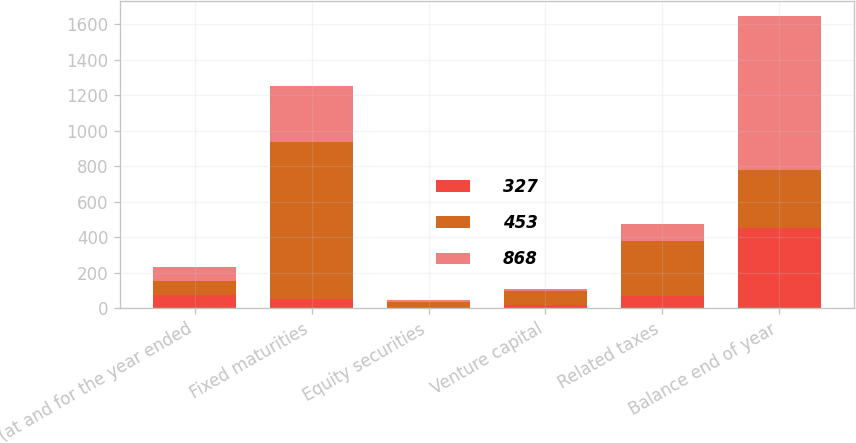<chart> <loc_0><loc_0><loc_500><loc_500><stacked_bar_chart><ecel><fcel>(at and for the year ended<fcel>Fixed maturities<fcel>Equity securities<fcel>Venture capital<fcel>Related taxes<fcel>Balance end of year<nl><fcel>327<fcel>78<fcel>55<fcel>4<fcel>19<fcel>69<fcel>453<nl><fcel>453<fcel>78<fcel>885<fcel>31<fcel>78<fcel>311<fcel>327<nl><fcel>868<fcel>78<fcel>315<fcel>11<fcel>11<fcel>98<fcel>868<nl></chart> 